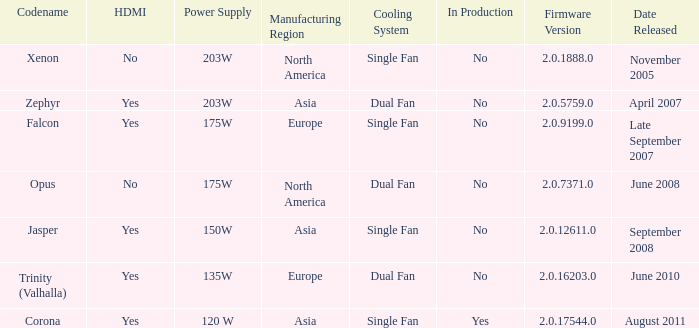Is Jasper being producted? No. Give me the full table as a dictionary. {'header': ['Codename', 'HDMI', 'Power Supply', 'Manufacturing Region', 'Cooling System', 'In Production', 'Firmware Version', 'Date Released'], 'rows': [['Xenon', 'No', '203W', 'North America', 'Single Fan', 'No', '2.0.1888.0', 'November 2005'], ['Zephyr', 'Yes', '203W', 'Asia', 'Dual Fan', 'No', '2.0.5759.0', 'April 2007'], ['Falcon', 'Yes', '175W', 'Europe', 'Single Fan', 'No', '2.0.9199.0', 'Late September 2007'], ['Opus', 'No', '175W', 'North America', 'Dual Fan', 'No', '2.0.7371.0', 'June 2008'], ['Jasper', 'Yes', '150W', 'Asia', 'Single Fan', 'No', '2.0.12611.0', 'September 2008'], ['Trinity (Valhalla)', 'Yes', '135W', 'Europe', 'Dual Fan', 'No', '2.0.16203.0', 'June 2010'], ['Corona', 'Yes', '120 W', 'Asia', 'Single Fan', 'Yes', '2.0.17544.0', 'August 2011']]} 